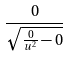Convert formula to latex. <formula><loc_0><loc_0><loc_500><loc_500>\frac { 0 } { \sqrt { \frac { 0 } { u ^ { 2 } } - 0 } }</formula> 